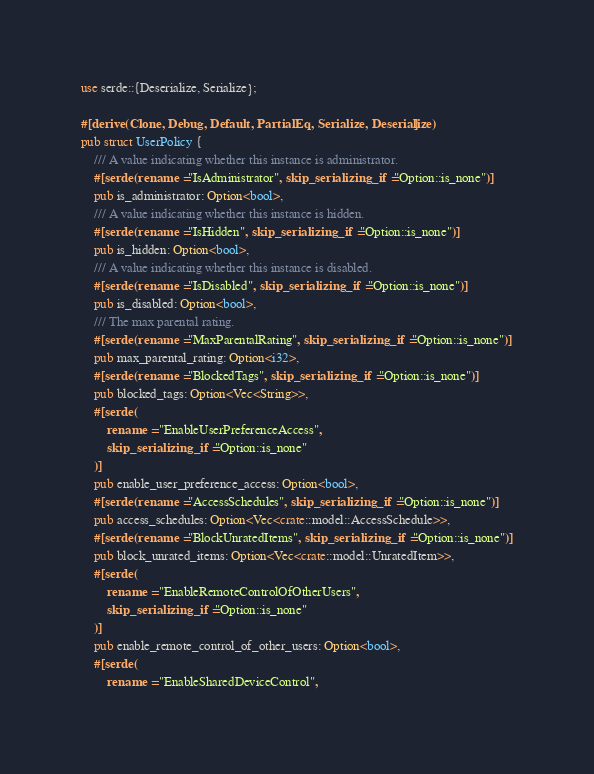<code> <loc_0><loc_0><loc_500><loc_500><_Rust_>use serde::{Deserialize, Serialize};

#[derive(Clone, Debug, Default, PartialEq, Serialize, Deserialize)]
pub struct UserPolicy {
    /// A value indicating whether this instance is administrator.
    #[serde(rename = "IsAdministrator", skip_serializing_if = "Option::is_none")]
    pub is_administrator: Option<bool>,
    /// A value indicating whether this instance is hidden.
    #[serde(rename = "IsHidden", skip_serializing_if = "Option::is_none")]
    pub is_hidden: Option<bool>,
    /// A value indicating whether this instance is disabled.
    #[serde(rename = "IsDisabled", skip_serializing_if = "Option::is_none")]
    pub is_disabled: Option<bool>,
    /// The max parental rating.
    #[serde(rename = "MaxParentalRating", skip_serializing_if = "Option::is_none")]
    pub max_parental_rating: Option<i32>,
    #[serde(rename = "BlockedTags", skip_serializing_if = "Option::is_none")]
    pub blocked_tags: Option<Vec<String>>,
    #[serde(
        rename = "EnableUserPreferenceAccess",
        skip_serializing_if = "Option::is_none"
    )]
    pub enable_user_preference_access: Option<bool>,
    #[serde(rename = "AccessSchedules", skip_serializing_if = "Option::is_none")]
    pub access_schedules: Option<Vec<crate::model::AccessSchedule>>,
    #[serde(rename = "BlockUnratedItems", skip_serializing_if = "Option::is_none")]
    pub block_unrated_items: Option<Vec<crate::model::UnratedItem>>,
    #[serde(
        rename = "EnableRemoteControlOfOtherUsers",
        skip_serializing_if = "Option::is_none"
    )]
    pub enable_remote_control_of_other_users: Option<bool>,
    #[serde(
        rename = "EnableSharedDeviceControl",</code> 